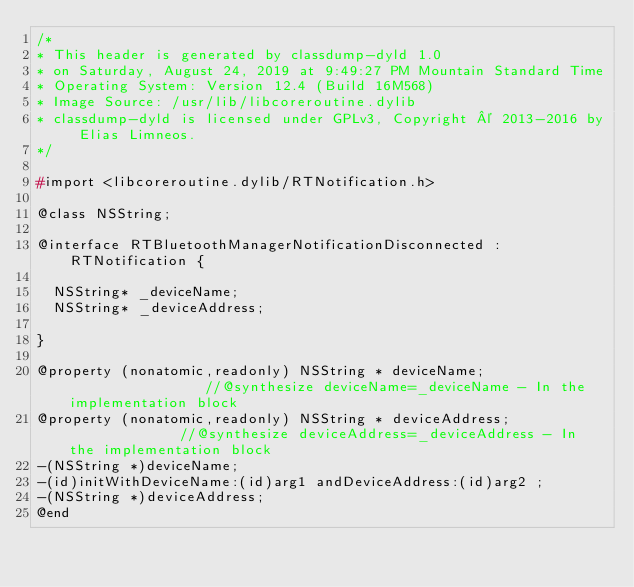Convert code to text. <code><loc_0><loc_0><loc_500><loc_500><_C_>/*
* This header is generated by classdump-dyld 1.0
* on Saturday, August 24, 2019 at 9:49:27 PM Mountain Standard Time
* Operating System: Version 12.4 (Build 16M568)
* Image Source: /usr/lib/libcoreroutine.dylib
* classdump-dyld is licensed under GPLv3, Copyright © 2013-2016 by Elias Limneos.
*/

#import <libcoreroutine.dylib/RTNotification.h>

@class NSString;

@interface RTBluetoothManagerNotificationDisconnected : RTNotification {

	NSString* _deviceName;
	NSString* _deviceAddress;

}

@property (nonatomic,readonly) NSString * deviceName;                 //@synthesize deviceName=_deviceName - In the implementation block
@property (nonatomic,readonly) NSString * deviceAddress;              //@synthesize deviceAddress=_deviceAddress - In the implementation block
-(NSString *)deviceName;
-(id)initWithDeviceName:(id)arg1 andDeviceAddress:(id)arg2 ;
-(NSString *)deviceAddress;
@end

</code> 